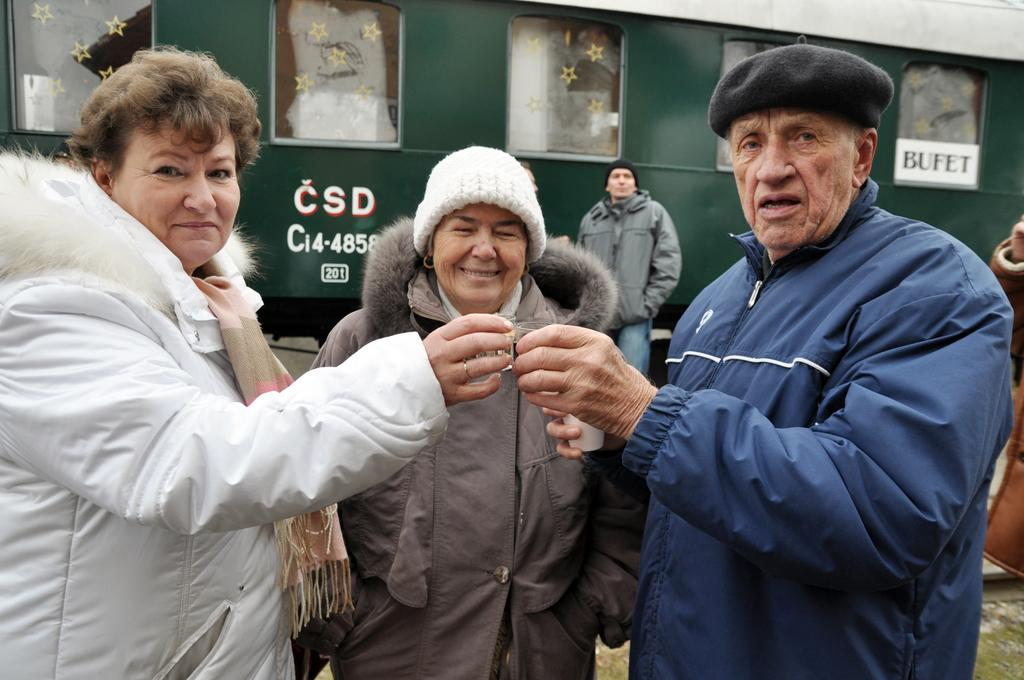How many persons are in the image? There are persons in the image. What are two of the persons doing in the image? Two persons are holding objects in their hands. What is a prominent feature in the background of the image? There is a train in the image. What can be seen on the train in the image? There is text written on the train. What verse can be heard being recited by the persons in the image? There is no indication in the image that the persons are reciting a verse, so it cannot be determined from the picture. 